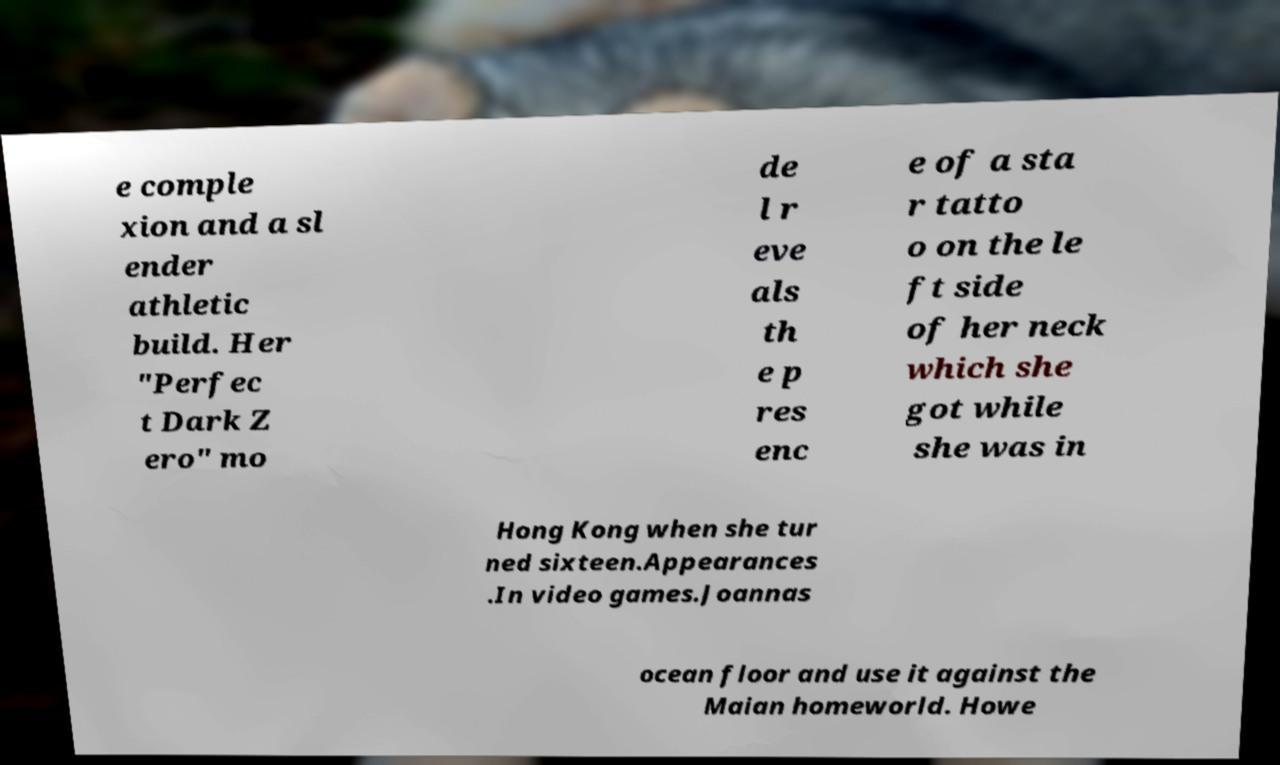Can you read and provide the text displayed in the image?This photo seems to have some interesting text. Can you extract and type it out for me? e comple xion and a sl ender athletic build. Her "Perfec t Dark Z ero" mo de l r eve als th e p res enc e of a sta r tatto o on the le ft side of her neck which she got while she was in Hong Kong when she tur ned sixteen.Appearances .In video games.Joannas ocean floor and use it against the Maian homeworld. Howe 